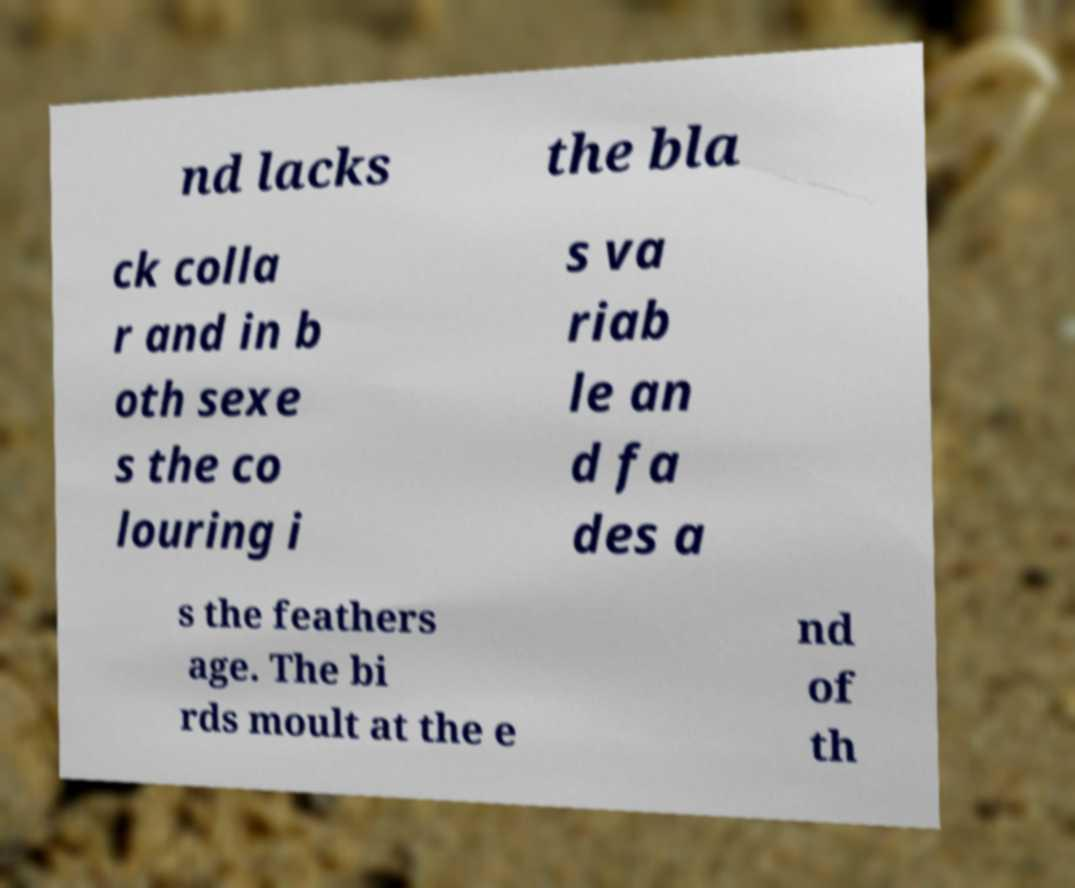I need the written content from this picture converted into text. Can you do that? nd lacks the bla ck colla r and in b oth sexe s the co louring i s va riab le an d fa des a s the feathers age. The bi rds moult at the e nd of th 